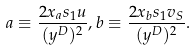<formula> <loc_0><loc_0><loc_500><loc_500>a \equiv \frac { 2 x _ { a } s _ { 1 } u } { ( y ^ { D } ) ^ { 2 } } , b \equiv \frac { 2 x _ { b } s _ { 1 } v _ { S } } { ( y ^ { D } ) ^ { 2 } } .</formula> 